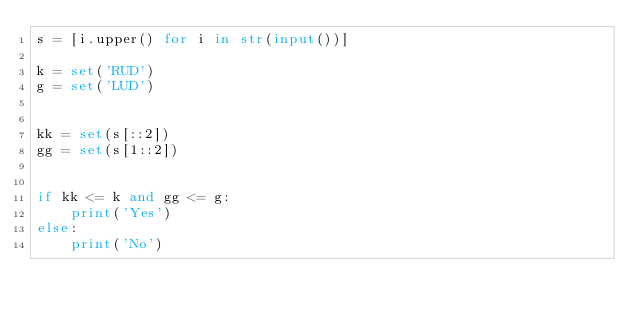Convert code to text. <code><loc_0><loc_0><loc_500><loc_500><_Python_>s = [i.upper() for i in str(input())]

k = set('RUD')
g = set('LUD')


kk = set(s[::2])
gg = set(s[1::2])


if kk <= k and gg <= g:
    print('Yes')
else:
    print('No')
</code> 